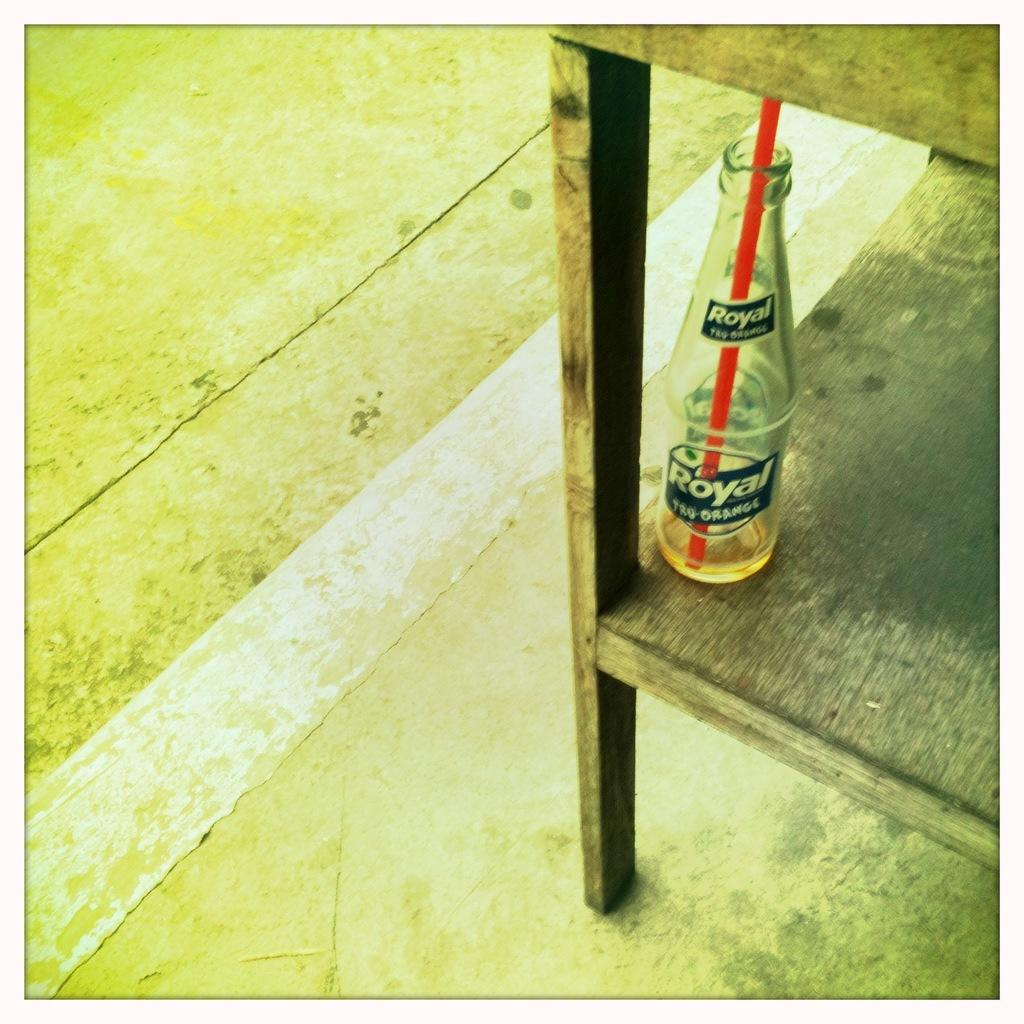What object in the image has a straw? The glass bottle in the image has a straw. What color is the straw? The straw is red. Where are the glass bottle and straw located? They are on a table. What is the table resting on? The table is on the floor. What arithmetic problem can be solved using the glass bottle and straw in the image? The glass bottle and straw in the image are not related to arithmetic problems; they are objects used for drinking, and there is no arithmetic problem present in the image. 